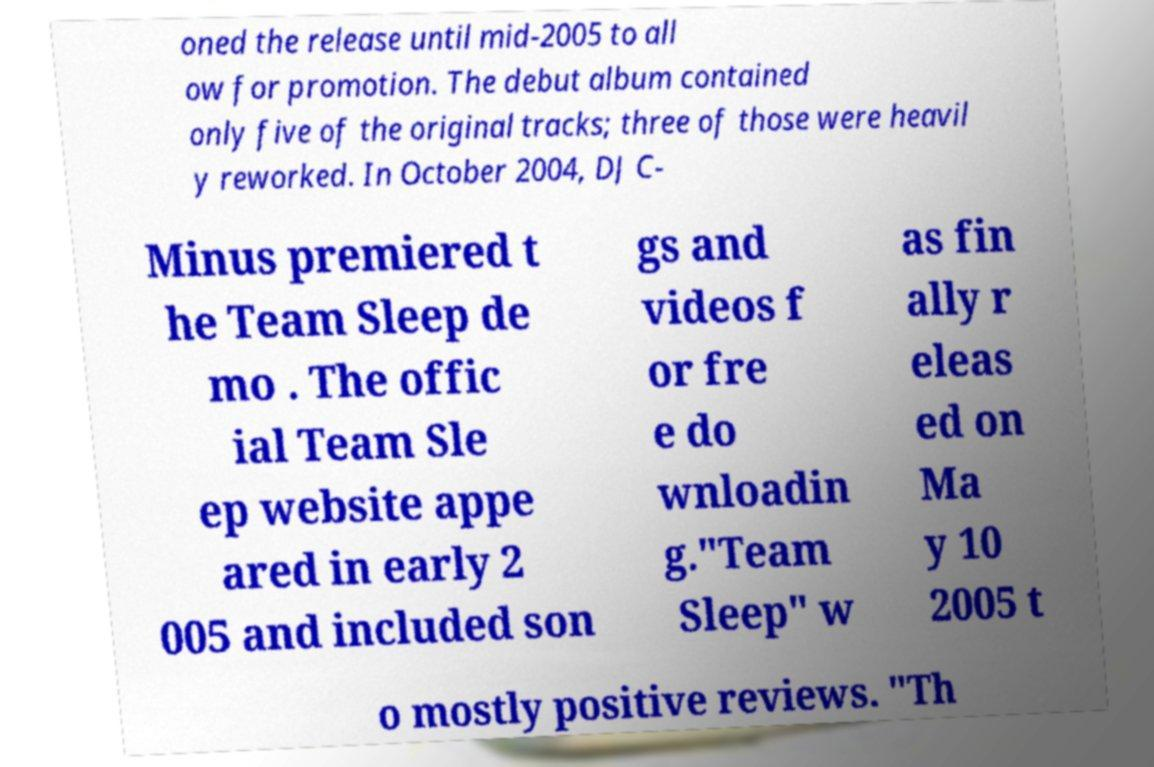Please read and relay the text visible in this image. What does it say? oned the release until mid-2005 to all ow for promotion. The debut album contained only five of the original tracks; three of those were heavil y reworked. In October 2004, DJ C- Minus premiered t he Team Sleep de mo . The offic ial Team Sle ep website appe ared in early 2 005 and included son gs and videos f or fre e do wnloadin g."Team Sleep" w as fin ally r eleas ed on Ma y 10 2005 t o mostly positive reviews. "Th 